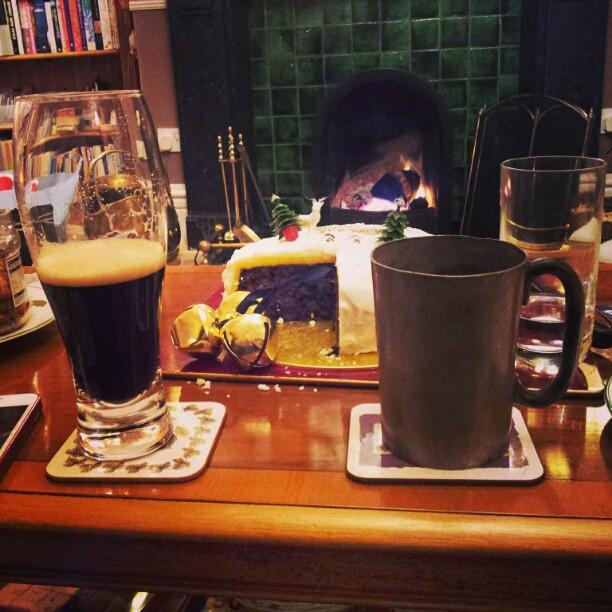What is underneath the mug?
Write a very short answer. Coaster. How many bells are sitting on the table?
Keep it brief. 2. Is there a drink in the glass?
Be succinct. Yes. 